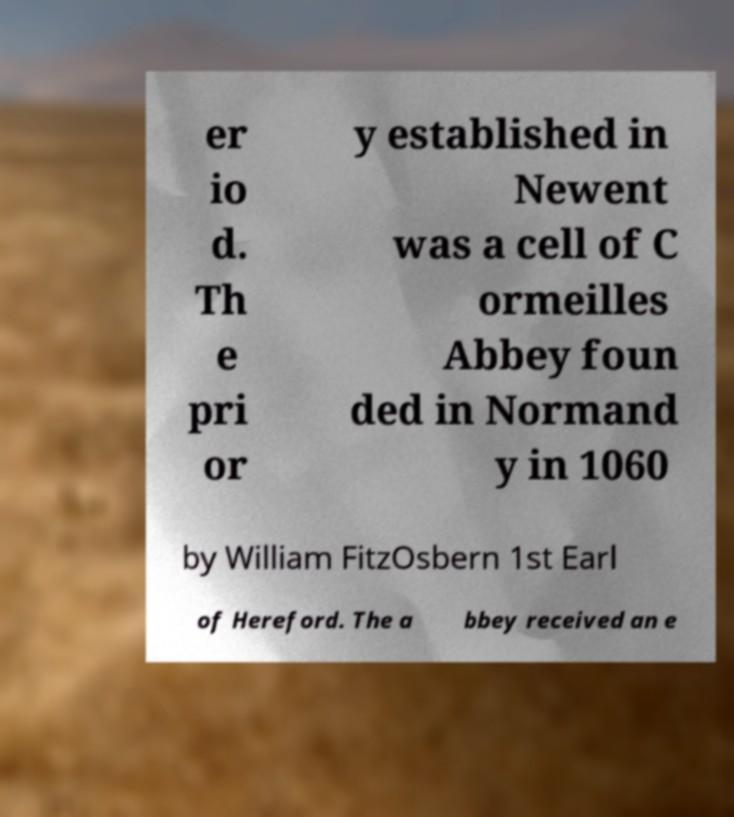Could you extract and type out the text from this image? er io d. Th e pri or y established in Newent was a cell of C ormeilles Abbey foun ded in Normand y in 1060 by William FitzOsbern 1st Earl of Hereford. The a bbey received an e 